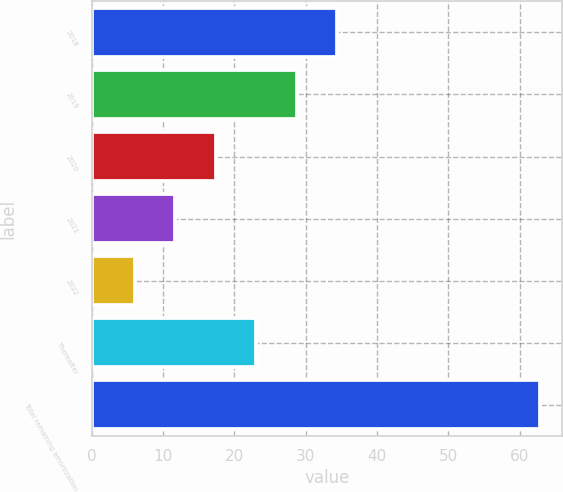Convert chart to OTSL. <chart><loc_0><loc_0><loc_500><loc_500><bar_chart><fcel>2018<fcel>2019<fcel>2020<fcel>2021<fcel>2022<fcel>Thereafter<fcel>Total remaining amortization<nl><fcel>34.4<fcel>28.72<fcel>17.36<fcel>11.68<fcel>6<fcel>23.04<fcel>62.8<nl></chart> 